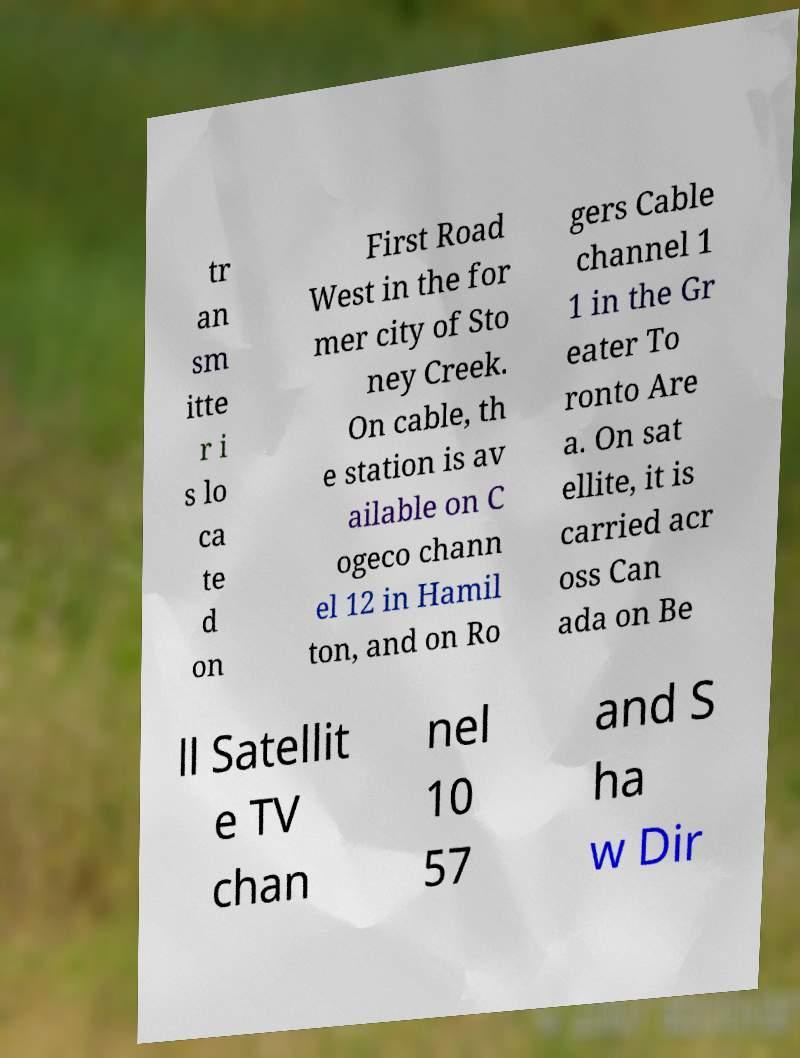Please read and relay the text visible in this image. What does it say? tr an sm itte r i s lo ca te d on First Road West in the for mer city of Sto ney Creek. On cable, th e station is av ailable on C ogeco chann el 12 in Hamil ton, and on Ro gers Cable channel 1 1 in the Gr eater To ronto Are a. On sat ellite, it is carried acr oss Can ada on Be ll Satellit e TV chan nel 10 57 and S ha w Dir 